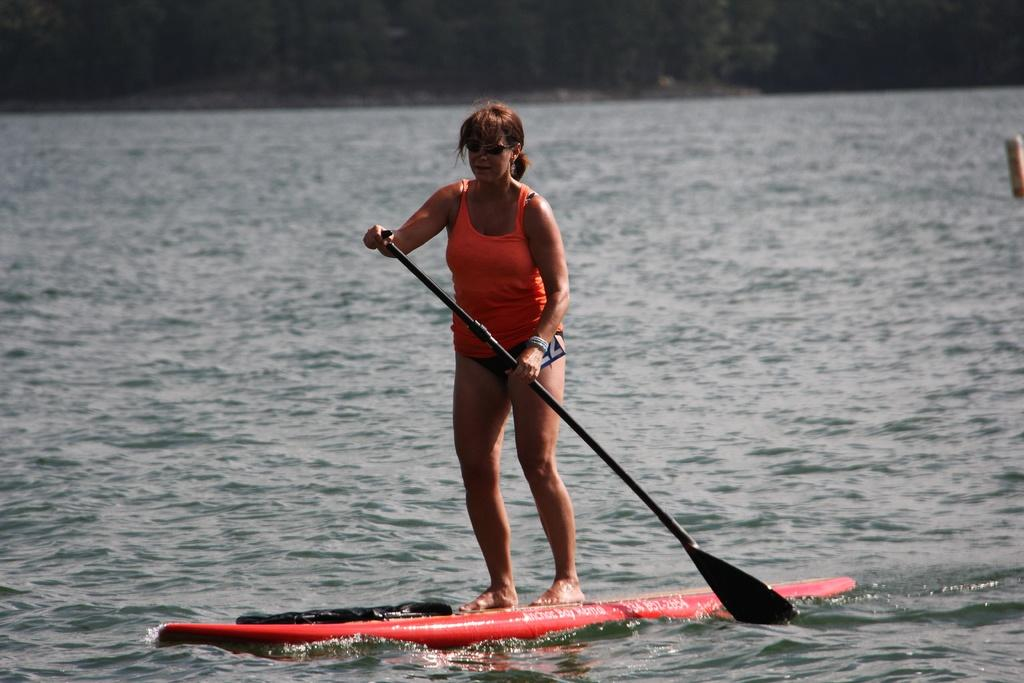Who is the main subject in the image? There is a woman in the image. What is the woman doing in the image? The woman is standing on a surfboard and rowing with a paddle. What is the environment like in the image? There is water around the woman. What type of food is the woman eating while standing on the surfboard? There is no food present in the image, and the woman is not eating anything. 